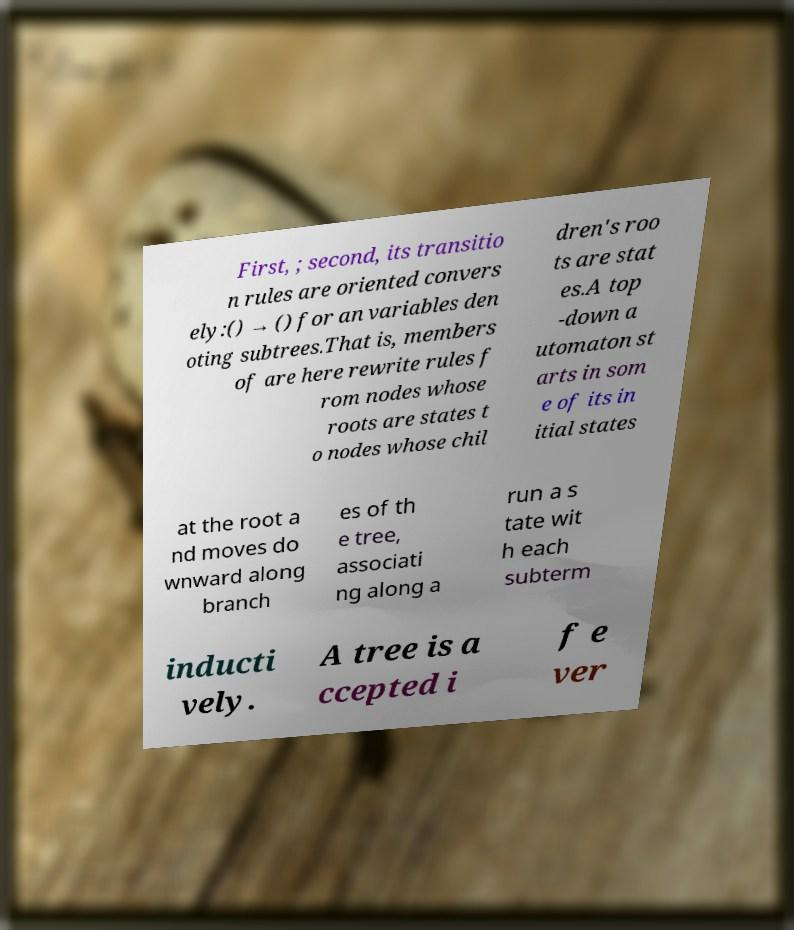What messages or text are displayed in this image? I need them in a readable, typed format. First, ; second, its transitio n rules are oriented convers ely:() → () for an variables den oting subtrees.That is, members of are here rewrite rules f rom nodes whose roots are states t o nodes whose chil dren's roo ts are stat es.A top -down a utomaton st arts in som e of its in itial states at the root a nd moves do wnward along branch es of th e tree, associati ng along a run a s tate wit h each subterm inducti vely. A tree is a ccepted i f e ver 